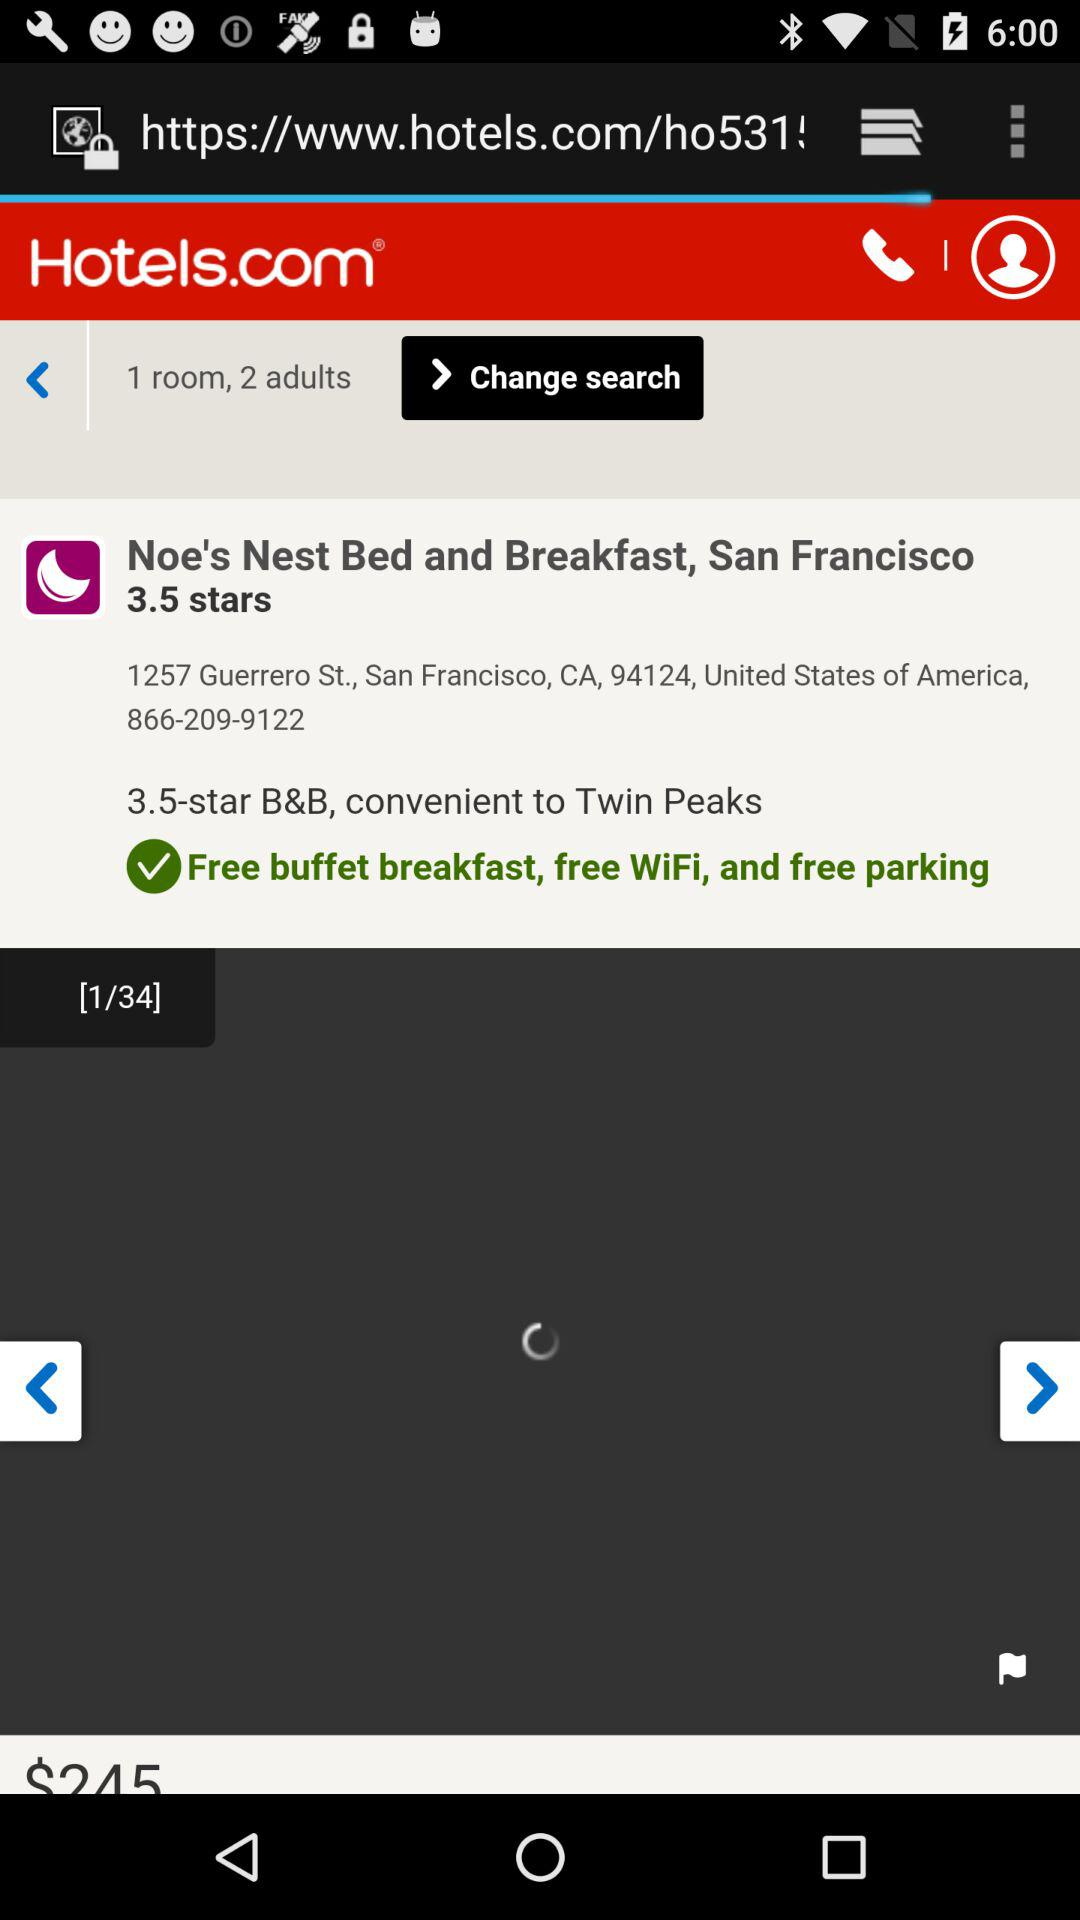What is the number of rooms selected? The number of rooms selected is 1. 